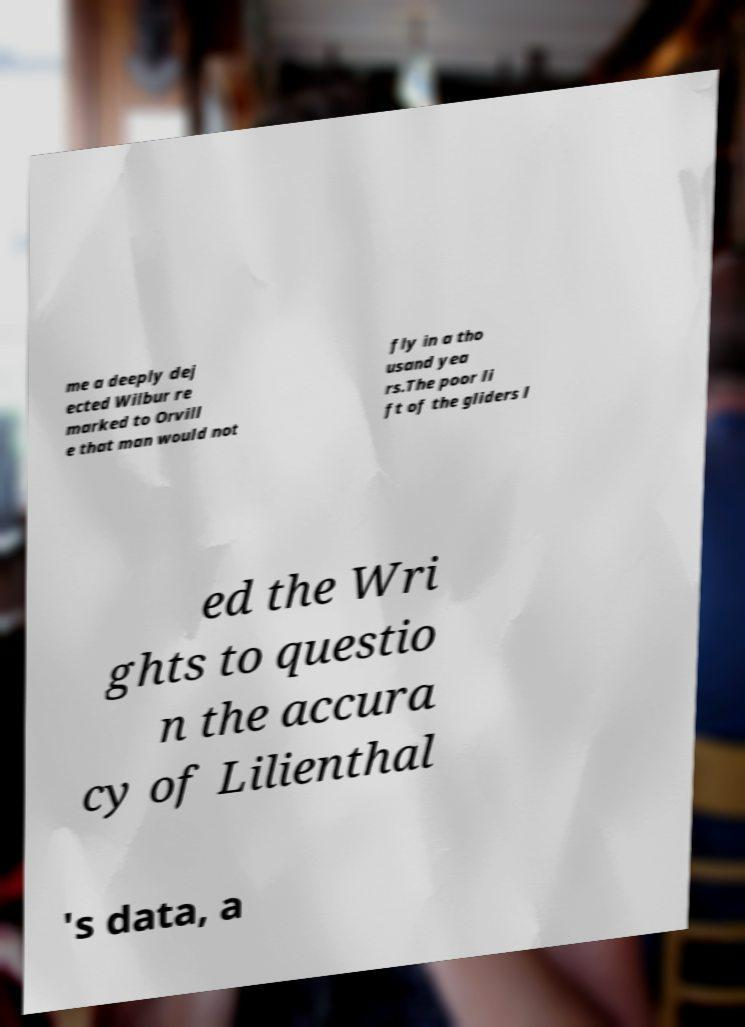Can you read and provide the text displayed in the image?This photo seems to have some interesting text. Can you extract and type it out for me? me a deeply dej ected Wilbur re marked to Orvill e that man would not fly in a tho usand yea rs.The poor li ft of the gliders l ed the Wri ghts to questio n the accura cy of Lilienthal 's data, a 